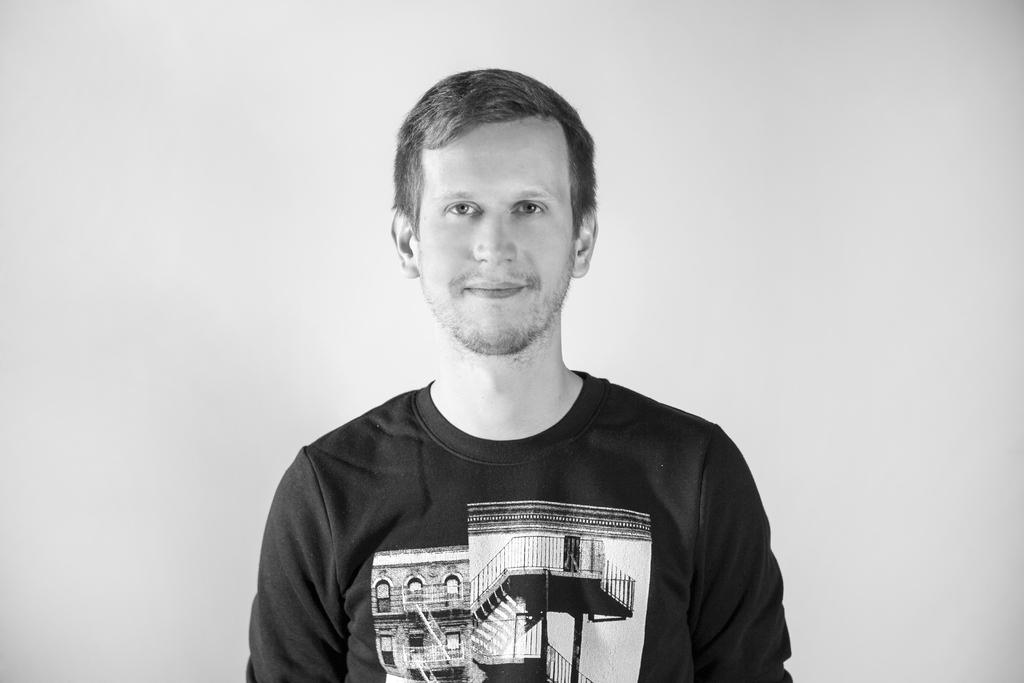What is the color scheme of the image? The image is black and white. Who or what is the main subject in the image? There is a person in the center of the image. What can be seen in the background of the image? There is a wall in the background of the image. What type of division is taking place in the image? There is no division taking place in the image; it is a still image featuring a person and a wall. Can you see a crib in the image? There is no crib present in the image. 